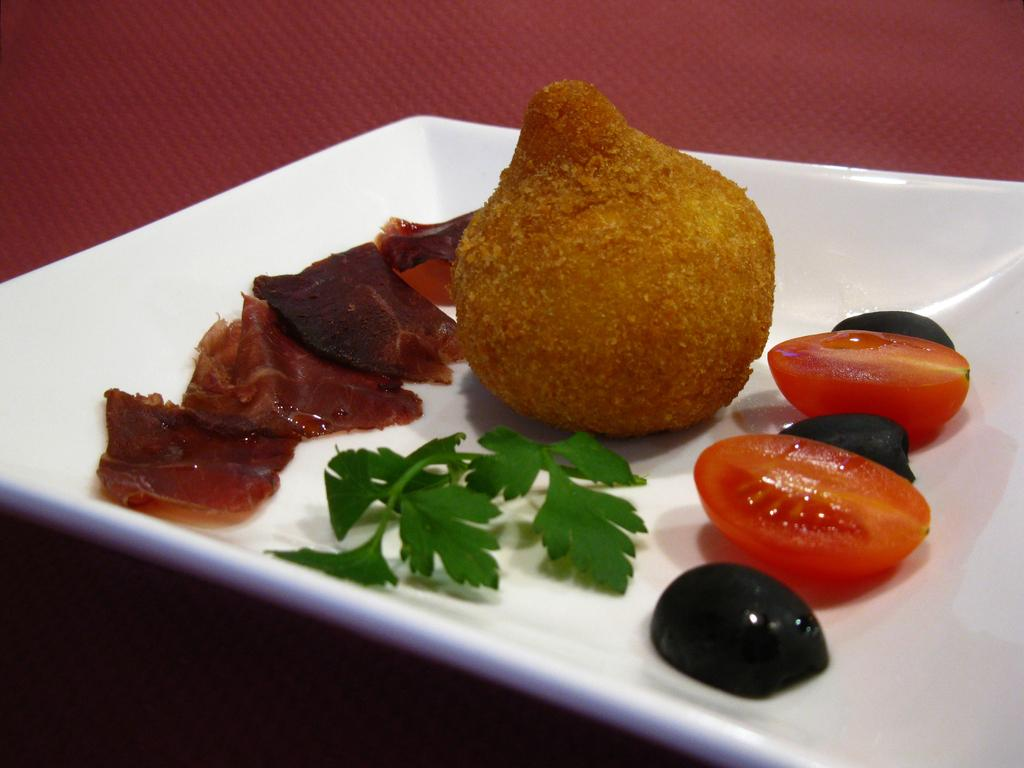What is the color of the plate in the image? The plate in the image is white. What is placed on the white plate? There are coriander leaves and two tomato pieces on the plate. Are there any other food items on the plate? Yes, there are other food items on the plate. What is the plate placed on? The plate is on a red color thing. What type of wool can be seen in the image? There is no wool present in the image. Is there a railway visible in the image? No, there is no railway visible in the image. 